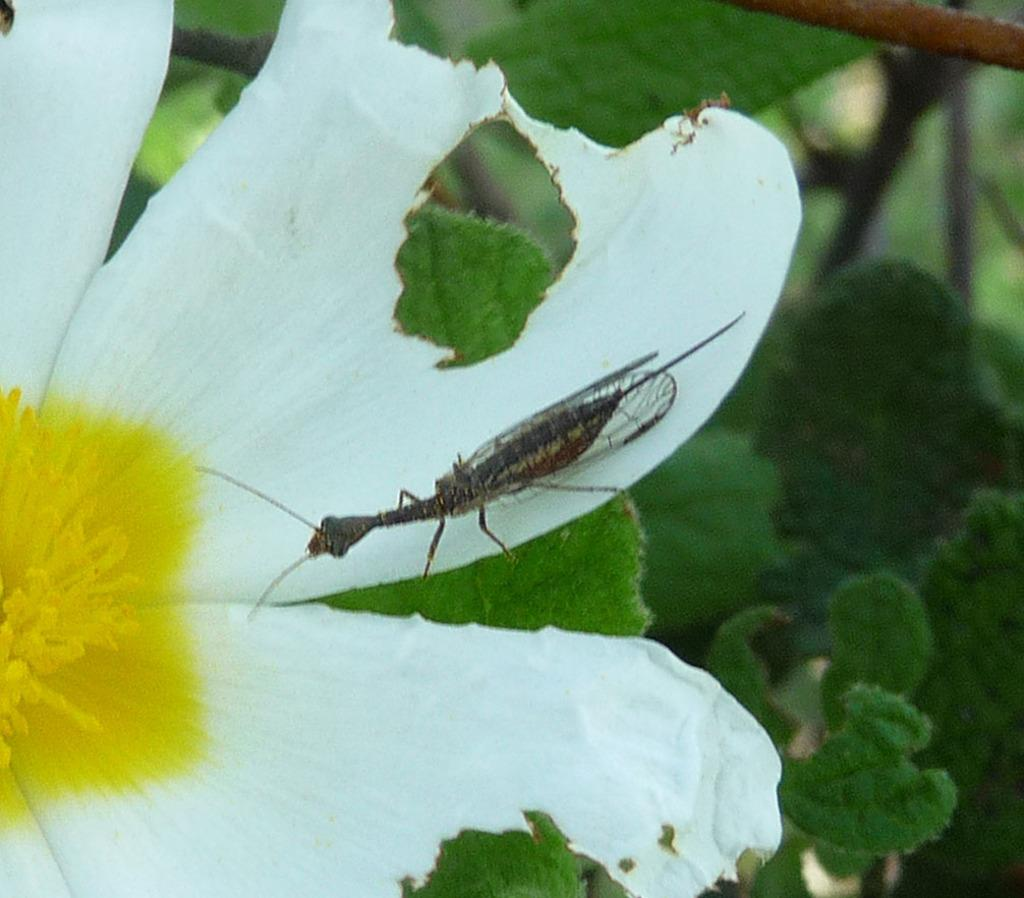What is on the flower in the image? There is an insect on a flower in the image. What can be seen in the background of the image? There are leaves visible in the background of the image. What type of magic is being performed by the insect in the image? There is no magic being performed by the insect in the image; it is simply sitting on a flower. 